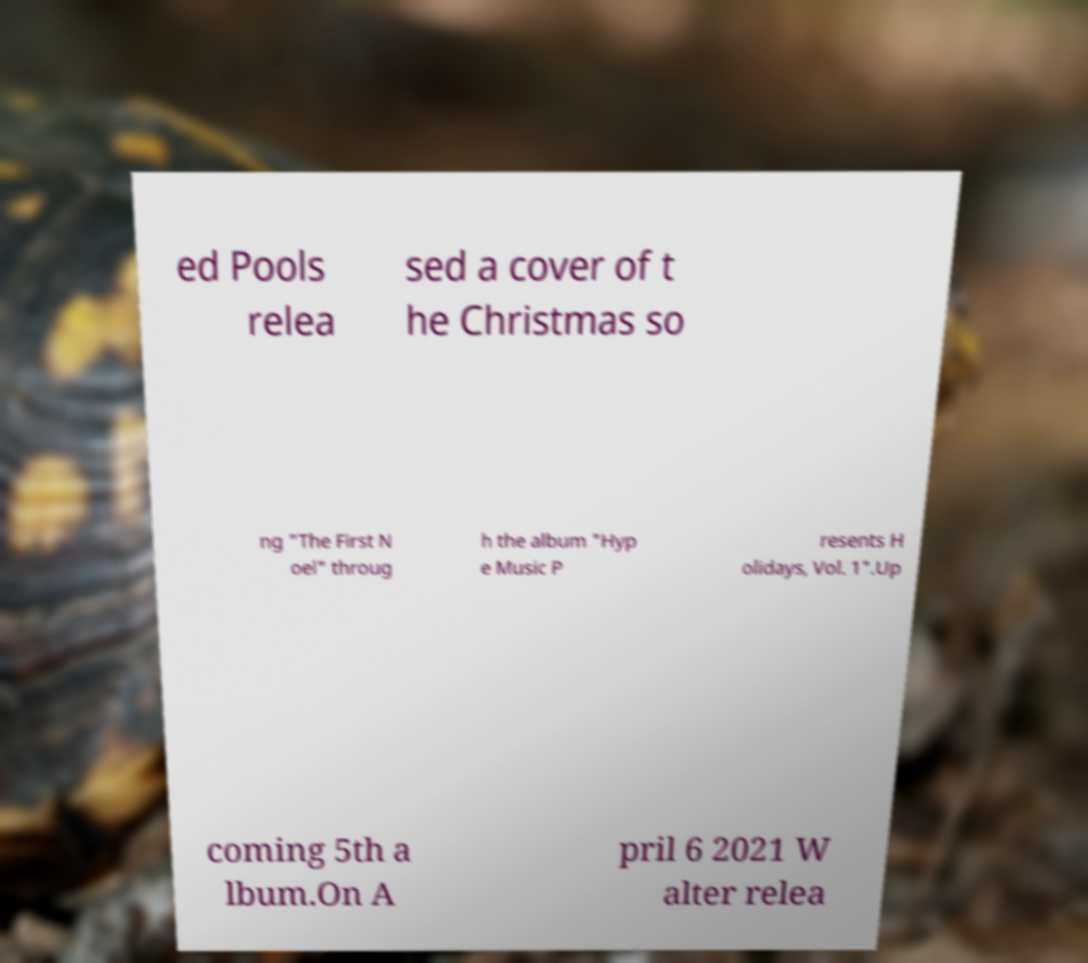Could you assist in decoding the text presented in this image and type it out clearly? ed Pools relea sed a cover of t he Christmas so ng "The First N oel" throug h the album "Hyp e Music P resents H olidays, Vol. 1".Up coming 5th a lbum.On A pril 6 2021 W alter relea 